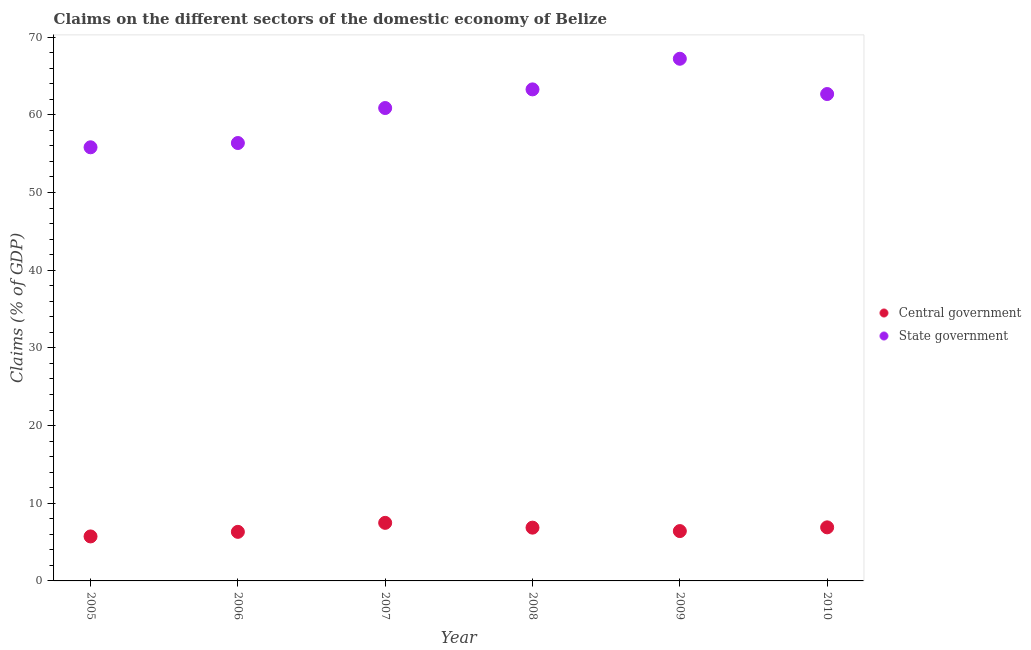Is the number of dotlines equal to the number of legend labels?
Offer a terse response. Yes. What is the claims on central government in 2005?
Provide a succinct answer. 5.73. Across all years, what is the maximum claims on central government?
Your answer should be very brief. 7.47. Across all years, what is the minimum claims on state government?
Offer a very short reply. 55.82. In which year was the claims on central government maximum?
Your answer should be very brief. 2007. What is the total claims on central government in the graph?
Ensure brevity in your answer.  39.69. What is the difference between the claims on state government in 2007 and that in 2008?
Your answer should be compact. -2.4. What is the difference between the claims on state government in 2007 and the claims on central government in 2009?
Provide a short and direct response. 54.46. What is the average claims on central government per year?
Offer a very short reply. 6.61. In the year 2009, what is the difference between the claims on central government and claims on state government?
Provide a succinct answer. -60.8. In how many years, is the claims on central government greater than 34 %?
Offer a terse response. 0. What is the ratio of the claims on state government in 2005 to that in 2009?
Make the answer very short. 0.83. Is the claims on central government in 2005 less than that in 2010?
Offer a terse response. Yes. What is the difference between the highest and the second highest claims on state government?
Your answer should be compact. 3.94. What is the difference between the highest and the lowest claims on central government?
Provide a succinct answer. 1.75. In how many years, is the claims on state government greater than the average claims on state government taken over all years?
Keep it short and to the point. 3. Is the sum of the claims on central government in 2008 and 2010 greater than the maximum claims on state government across all years?
Your answer should be very brief. No. Is the claims on central government strictly greater than the claims on state government over the years?
Keep it short and to the point. No. What is the difference between two consecutive major ticks on the Y-axis?
Provide a short and direct response. 10. Are the values on the major ticks of Y-axis written in scientific E-notation?
Keep it short and to the point. No. Does the graph contain any zero values?
Give a very brief answer. No. Does the graph contain grids?
Make the answer very short. No. Where does the legend appear in the graph?
Offer a terse response. Center right. How many legend labels are there?
Offer a terse response. 2. What is the title of the graph?
Offer a terse response. Claims on the different sectors of the domestic economy of Belize. What is the label or title of the X-axis?
Your answer should be very brief. Year. What is the label or title of the Y-axis?
Your response must be concise. Claims (% of GDP). What is the Claims (% of GDP) of Central government in 2005?
Offer a very short reply. 5.73. What is the Claims (% of GDP) of State government in 2005?
Give a very brief answer. 55.82. What is the Claims (% of GDP) in Central government in 2006?
Ensure brevity in your answer.  6.32. What is the Claims (% of GDP) in State government in 2006?
Make the answer very short. 56.37. What is the Claims (% of GDP) of Central government in 2007?
Provide a short and direct response. 7.47. What is the Claims (% of GDP) in State government in 2007?
Make the answer very short. 60.87. What is the Claims (% of GDP) of Central government in 2008?
Provide a succinct answer. 6.86. What is the Claims (% of GDP) in State government in 2008?
Offer a very short reply. 63.27. What is the Claims (% of GDP) of Central government in 2009?
Keep it short and to the point. 6.42. What is the Claims (% of GDP) in State government in 2009?
Make the answer very short. 67.22. What is the Claims (% of GDP) of Central government in 2010?
Your answer should be very brief. 6.9. What is the Claims (% of GDP) in State government in 2010?
Provide a short and direct response. 62.67. Across all years, what is the maximum Claims (% of GDP) in Central government?
Provide a short and direct response. 7.47. Across all years, what is the maximum Claims (% of GDP) in State government?
Ensure brevity in your answer.  67.22. Across all years, what is the minimum Claims (% of GDP) in Central government?
Offer a very short reply. 5.73. Across all years, what is the minimum Claims (% of GDP) in State government?
Make the answer very short. 55.82. What is the total Claims (% of GDP) in Central government in the graph?
Offer a very short reply. 39.69. What is the total Claims (% of GDP) of State government in the graph?
Your answer should be compact. 366.23. What is the difference between the Claims (% of GDP) of Central government in 2005 and that in 2006?
Your answer should be compact. -0.59. What is the difference between the Claims (% of GDP) of State government in 2005 and that in 2006?
Keep it short and to the point. -0.55. What is the difference between the Claims (% of GDP) in Central government in 2005 and that in 2007?
Your response must be concise. -1.75. What is the difference between the Claims (% of GDP) of State government in 2005 and that in 2007?
Your answer should be very brief. -5.05. What is the difference between the Claims (% of GDP) of Central government in 2005 and that in 2008?
Your answer should be compact. -1.13. What is the difference between the Claims (% of GDP) in State government in 2005 and that in 2008?
Offer a terse response. -7.46. What is the difference between the Claims (% of GDP) of Central government in 2005 and that in 2009?
Offer a very short reply. -0.69. What is the difference between the Claims (% of GDP) of State government in 2005 and that in 2009?
Your answer should be compact. -11.4. What is the difference between the Claims (% of GDP) in Central government in 2005 and that in 2010?
Your answer should be very brief. -1.17. What is the difference between the Claims (% of GDP) of State government in 2005 and that in 2010?
Offer a very short reply. -6.86. What is the difference between the Claims (% of GDP) in Central government in 2006 and that in 2007?
Your answer should be very brief. -1.16. What is the difference between the Claims (% of GDP) in State government in 2006 and that in 2007?
Give a very brief answer. -4.5. What is the difference between the Claims (% of GDP) in Central government in 2006 and that in 2008?
Ensure brevity in your answer.  -0.54. What is the difference between the Claims (% of GDP) of State government in 2006 and that in 2008?
Offer a very short reply. -6.9. What is the difference between the Claims (% of GDP) of Central government in 2006 and that in 2009?
Provide a short and direct response. -0.1. What is the difference between the Claims (% of GDP) in State government in 2006 and that in 2009?
Make the answer very short. -10.85. What is the difference between the Claims (% of GDP) in Central government in 2006 and that in 2010?
Ensure brevity in your answer.  -0.58. What is the difference between the Claims (% of GDP) in State government in 2006 and that in 2010?
Offer a terse response. -6.31. What is the difference between the Claims (% of GDP) in Central government in 2007 and that in 2008?
Provide a short and direct response. 0.62. What is the difference between the Claims (% of GDP) of State government in 2007 and that in 2008?
Make the answer very short. -2.4. What is the difference between the Claims (% of GDP) in Central government in 2007 and that in 2009?
Your answer should be very brief. 1.06. What is the difference between the Claims (% of GDP) of State government in 2007 and that in 2009?
Your answer should be very brief. -6.34. What is the difference between the Claims (% of GDP) in Central government in 2007 and that in 2010?
Provide a short and direct response. 0.58. What is the difference between the Claims (% of GDP) of State government in 2007 and that in 2010?
Your answer should be very brief. -1.8. What is the difference between the Claims (% of GDP) of Central government in 2008 and that in 2009?
Your response must be concise. 0.44. What is the difference between the Claims (% of GDP) of State government in 2008 and that in 2009?
Your answer should be compact. -3.94. What is the difference between the Claims (% of GDP) in Central government in 2008 and that in 2010?
Ensure brevity in your answer.  -0.04. What is the difference between the Claims (% of GDP) of State government in 2008 and that in 2010?
Your response must be concise. 0.6. What is the difference between the Claims (% of GDP) of Central government in 2009 and that in 2010?
Offer a very short reply. -0.48. What is the difference between the Claims (% of GDP) of State government in 2009 and that in 2010?
Keep it short and to the point. 4.54. What is the difference between the Claims (% of GDP) of Central government in 2005 and the Claims (% of GDP) of State government in 2006?
Your response must be concise. -50.64. What is the difference between the Claims (% of GDP) in Central government in 2005 and the Claims (% of GDP) in State government in 2007?
Give a very brief answer. -55.15. What is the difference between the Claims (% of GDP) in Central government in 2005 and the Claims (% of GDP) in State government in 2008?
Offer a terse response. -57.55. What is the difference between the Claims (% of GDP) of Central government in 2005 and the Claims (% of GDP) of State government in 2009?
Keep it short and to the point. -61.49. What is the difference between the Claims (% of GDP) in Central government in 2005 and the Claims (% of GDP) in State government in 2010?
Give a very brief answer. -56.95. What is the difference between the Claims (% of GDP) of Central government in 2006 and the Claims (% of GDP) of State government in 2007?
Offer a very short reply. -54.56. What is the difference between the Claims (% of GDP) of Central government in 2006 and the Claims (% of GDP) of State government in 2008?
Ensure brevity in your answer.  -56.96. What is the difference between the Claims (% of GDP) in Central government in 2006 and the Claims (% of GDP) in State government in 2009?
Make the answer very short. -60.9. What is the difference between the Claims (% of GDP) of Central government in 2006 and the Claims (% of GDP) of State government in 2010?
Your response must be concise. -56.36. What is the difference between the Claims (% of GDP) of Central government in 2007 and the Claims (% of GDP) of State government in 2008?
Your answer should be very brief. -55.8. What is the difference between the Claims (% of GDP) of Central government in 2007 and the Claims (% of GDP) of State government in 2009?
Provide a succinct answer. -59.74. What is the difference between the Claims (% of GDP) of Central government in 2007 and the Claims (% of GDP) of State government in 2010?
Offer a terse response. -55.2. What is the difference between the Claims (% of GDP) in Central government in 2008 and the Claims (% of GDP) in State government in 2009?
Provide a succinct answer. -60.36. What is the difference between the Claims (% of GDP) in Central government in 2008 and the Claims (% of GDP) in State government in 2010?
Your answer should be very brief. -55.82. What is the difference between the Claims (% of GDP) of Central government in 2009 and the Claims (% of GDP) of State government in 2010?
Make the answer very short. -56.26. What is the average Claims (% of GDP) in Central government per year?
Give a very brief answer. 6.61. What is the average Claims (% of GDP) of State government per year?
Your answer should be very brief. 61.04. In the year 2005, what is the difference between the Claims (% of GDP) in Central government and Claims (% of GDP) in State government?
Your response must be concise. -50.09. In the year 2006, what is the difference between the Claims (% of GDP) in Central government and Claims (% of GDP) in State government?
Ensure brevity in your answer.  -50.05. In the year 2007, what is the difference between the Claims (% of GDP) of Central government and Claims (% of GDP) of State government?
Make the answer very short. -53.4. In the year 2008, what is the difference between the Claims (% of GDP) in Central government and Claims (% of GDP) in State government?
Provide a succinct answer. -56.42. In the year 2009, what is the difference between the Claims (% of GDP) of Central government and Claims (% of GDP) of State government?
Keep it short and to the point. -60.8. In the year 2010, what is the difference between the Claims (% of GDP) of Central government and Claims (% of GDP) of State government?
Keep it short and to the point. -55.78. What is the ratio of the Claims (% of GDP) in Central government in 2005 to that in 2006?
Your answer should be very brief. 0.91. What is the ratio of the Claims (% of GDP) of State government in 2005 to that in 2006?
Give a very brief answer. 0.99. What is the ratio of the Claims (% of GDP) of Central government in 2005 to that in 2007?
Your answer should be very brief. 0.77. What is the ratio of the Claims (% of GDP) of State government in 2005 to that in 2007?
Your answer should be compact. 0.92. What is the ratio of the Claims (% of GDP) of Central government in 2005 to that in 2008?
Offer a very short reply. 0.83. What is the ratio of the Claims (% of GDP) in State government in 2005 to that in 2008?
Provide a succinct answer. 0.88. What is the ratio of the Claims (% of GDP) of Central government in 2005 to that in 2009?
Keep it short and to the point. 0.89. What is the ratio of the Claims (% of GDP) in State government in 2005 to that in 2009?
Offer a terse response. 0.83. What is the ratio of the Claims (% of GDP) in Central government in 2005 to that in 2010?
Your answer should be compact. 0.83. What is the ratio of the Claims (% of GDP) of State government in 2005 to that in 2010?
Make the answer very short. 0.89. What is the ratio of the Claims (% of GDP) in Central government in 2006 to that in 2007?
Keep it short and to the point. 0.85. What is the ratio of the Claims (% of GDP) of State government in 2006 to that in 2007?
Your answer should be very brief. 0.93. What is the ratio of the Claims (% of GDP) in Central government in 2006 to that in 2008?
Make the answer very short. 0.92. What is the ratio of the Claims (% of GDP) of State government in 2006 to that in 2008?
Give a very brief answer. 0.89. What is the ratio of the Claims (% of GDP) in Central government in 2006 to that in 2009?
Offer a very short reply. 0.98. What is the ratio of the Claims (% of GDP) in State government in 2006 to that in 2009?
Give a very brief answer. 0.84. What is the ratio of the Claims (% of GDP) in Central government in 2006 to that in 2010?
Provide a succinct answer. 0.92. What is the ratio of the Claims (% of GDP) of State government in 2006 to that in 2010?
Keep it short and to the point. 0.9. What is the ratio of the Claims (% of GDP) of Central government in 2007 to that in 2008?
Your answer should be compact. 1.09. What is the ratio of the Claims (% of GDP) of State government in 2007 to that in 2008?
Keep it short and to the point. 0.96. What is the ratio of the Claims (% of GDP) of Central government in 2007 to that in 2009?
Your answer should be very brief. 1.17. What is the ratio of the Claims (% of GDP) in State government in 2007 to that in 2009?
Offer a very short reply. 0.91. What is the ratio of the Claims (% of GDP) in Central government in 2007 to that in 2010?
Make the answer very short. 1.08. What is the ratio of the Claims (% of GDP) in State government in 2007 to that in 2010?
Your answer should be very brief. 0.97. What is the ratio of the Claims (% of GDP) in Central government in 2008 to that in 2009?
Give a very brief answer. 1.07. What is the ratio of the Claims (% of GDP) of State government in 2008 to that in 2009?
Your answer should be compact. 0.94. What is the ratio of the Claims (% of GDP) of Central government in 2008 to that in 2010?
Give a very brief answer. 0.99. What is the ratio of the Claims (% of GDP) of State government in 2008 to that in 2010?
Your response must be concise. 1.01. What is the ratio of the Claims (% of GDP) of Central government in 2009 to that in 2010?
Provide a succinct answer. 0.93. What is the ratio of the Claims (% of GDP) in State government in 2009 to that in 2010?
Provide a short and direct response. 1.07. What is the difference between the highest and the second highest Claims (% of GDP) of Central government?
Your answer should be very brief. 0.58. What is the difference between the highest and the second highest Claims (% of GDP) of State government?
Provide a succinct answer. 3.94. What is the difference between the highest and the lowest Claims (% of GDP) in Central government?
Offer a very short reply. 1.75. What is the difference between the highest and the lowest Claims (% of GDP) of State government?
Your response must be concise. 11.4. 